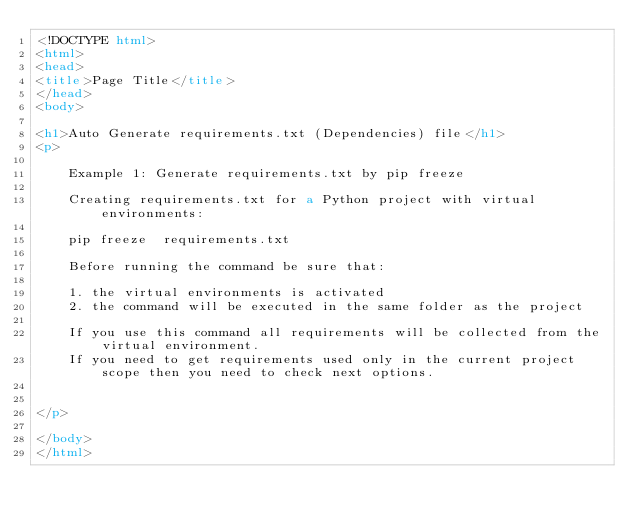<code> <loc_0><loc_0><loc_500><loc_500><_HTML_><!DOCTYPE html>
<html>
<head>
<title>Page Title</title>
</head>
<body>

<h1>Auto Generate requirements.txt (Dependencies) file</h1>
<p>
    
    Example 1: Generate requirements.txt by pip freeze

    Creating requirements.txt for a Python project with virtual environments: 

    pip freeze  requirements.txt

    Before running the command be sure that:

    1. the virtual environments is activated
    2. the command will be executed in the same folder as the project

    If you use this command all requirements will be collected from the virtual environment. 
    If you need to get requirements used only in the current project scope then you need to check next options.


</p>

</body>
</html></code> 